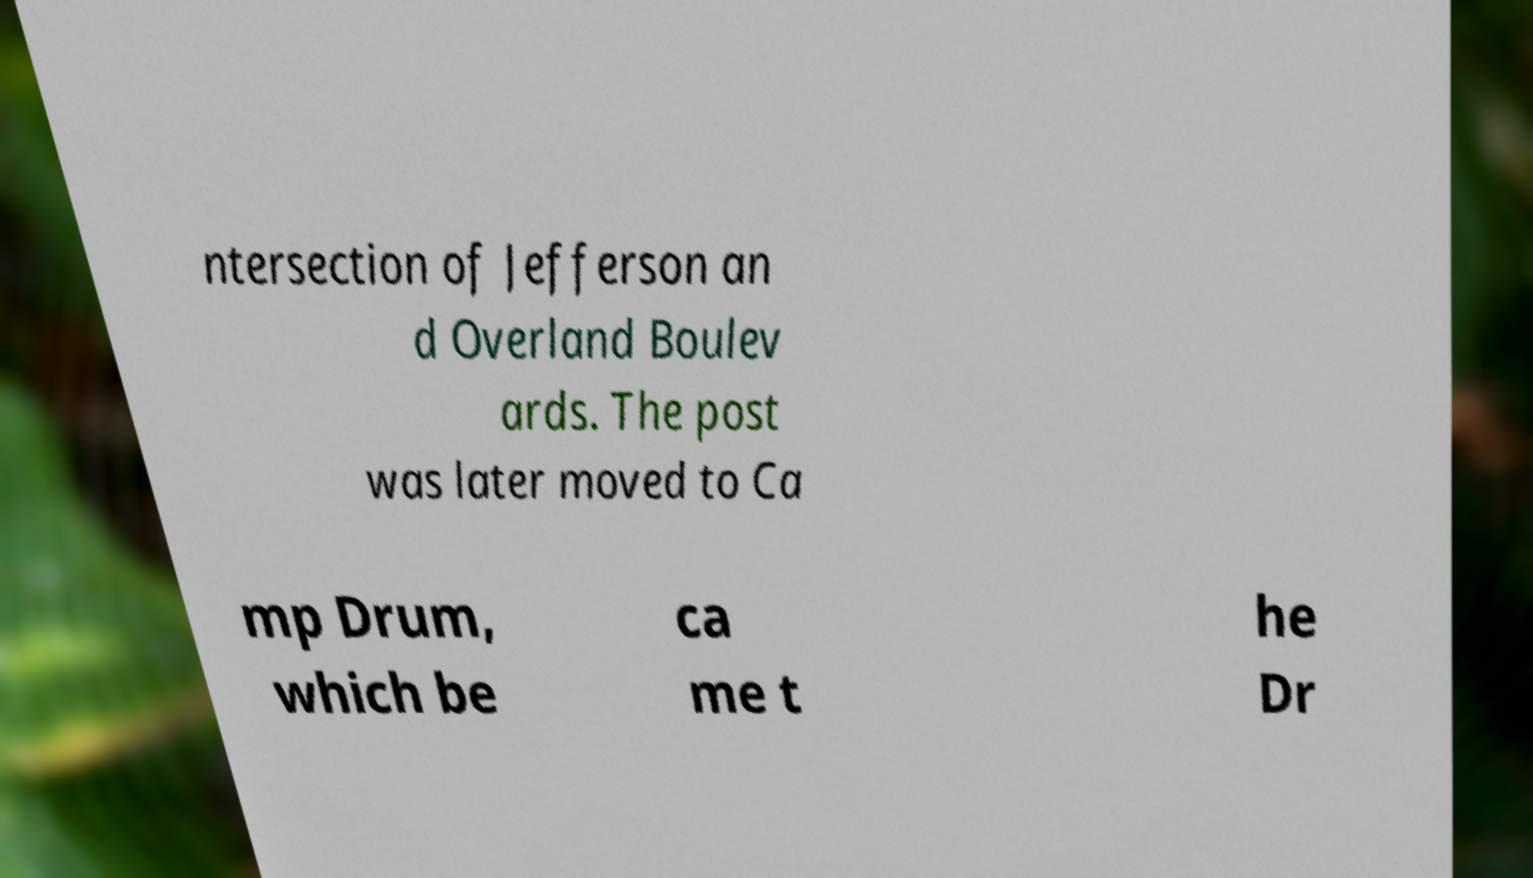Can you read and provide the text displayed in the image?This photo seems to have some interesting text. Can you extract and type it out for me? ntersection of Jefferson an d Overland Boulev ards. The post was later moved to Ca mp Drum, which be ca me t he Dr 